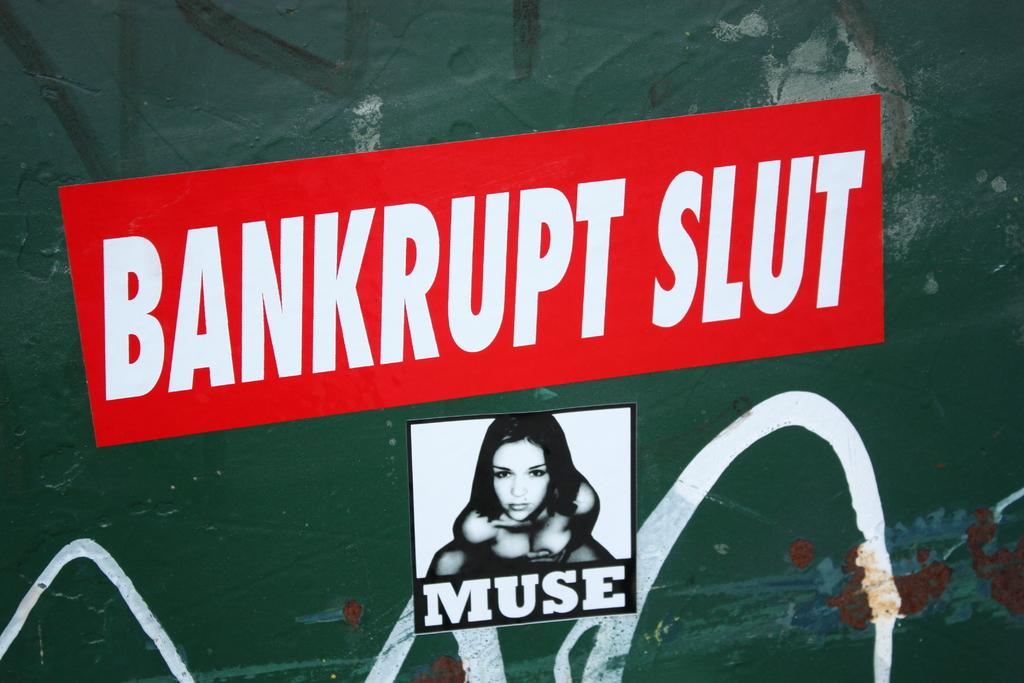<image>
Describe the image concisely. A red sticker with white words reads Bankrupt Slut. 